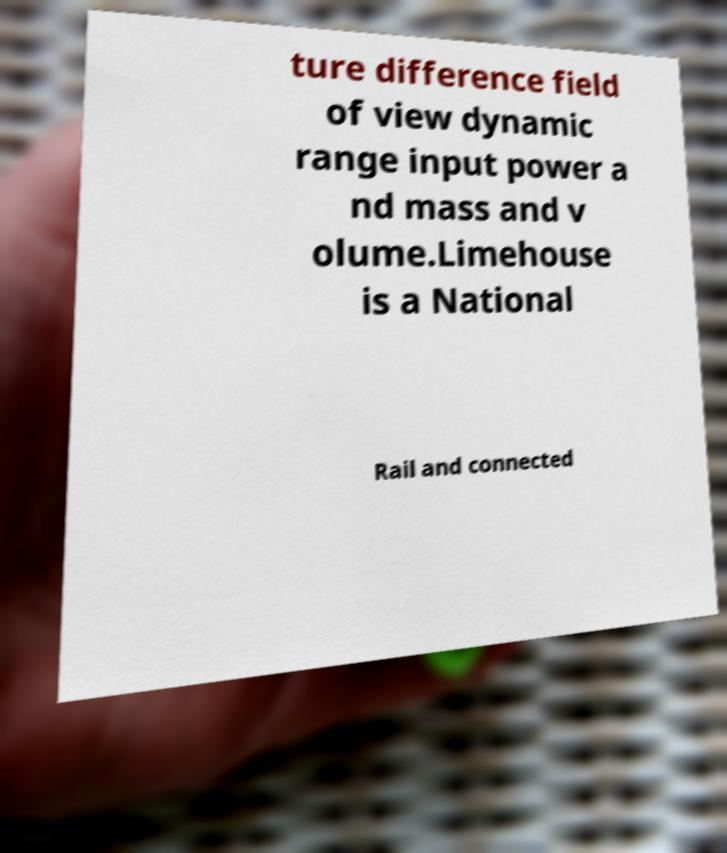For documentation purposes, I need the text within this image transcribed. Could you provide that? ture difference field of view dynamic range input power a nd mass and v olume.Limehouse is a National Rail and connected 